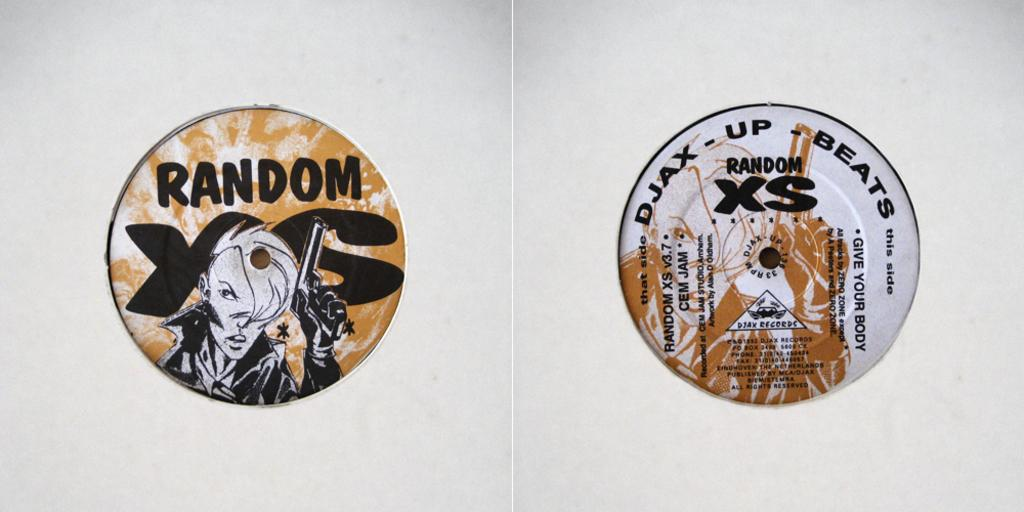<image>
Create a compact narrative representing the image presented. Two round CD-like objects that read RANDOM XS. 